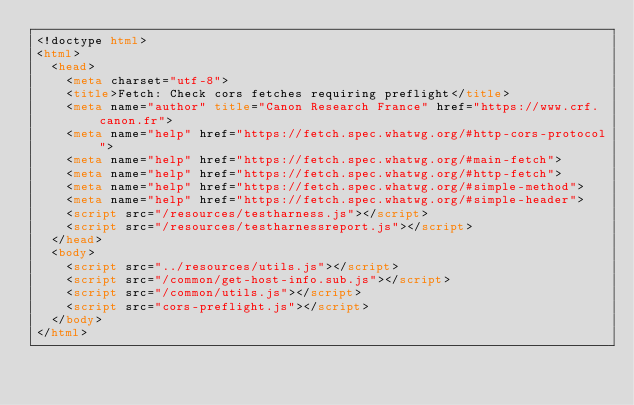<code> <loc_0><loc_0><loc_500><loc_500><_HTML_><!doctype html>
<html>
  <head>
    <meta charset="utf-8">
    <title>Fetch: Check cors fetches requiring preflight</title>
    <meta name="author" title="Canon Research France" href="https://www.crf.canon.fr">
    <meta name="help" href="https://fetch.spec.whatwg.org/#http-cors-protocol">
    <meta name="help" href="https://fetch.spec.whatwg.org/#main-fetch">
    <meta name="help" href="https://fetch.spec.whatwg.org/#http-fetch">
    <meta name="help" href="https://fetch.spec.whatwg.org/#simple-method">
    <meta name="help" href="https://fetch.spec.whatwg.org/#simple-header">
    <script src="/resources/testharness.js"></script>
    <script src="/resources/testharnessreport.js"></script>
  </head>
  <body>
    <script src="../resources/utils.js"></script>
    <script src="/common/get-host-info.sub.js"></script>
    <script src="/common/utils.js"></script>
    <script src="cors-preflight.js"></script>
  </body>
</html>
</code> 